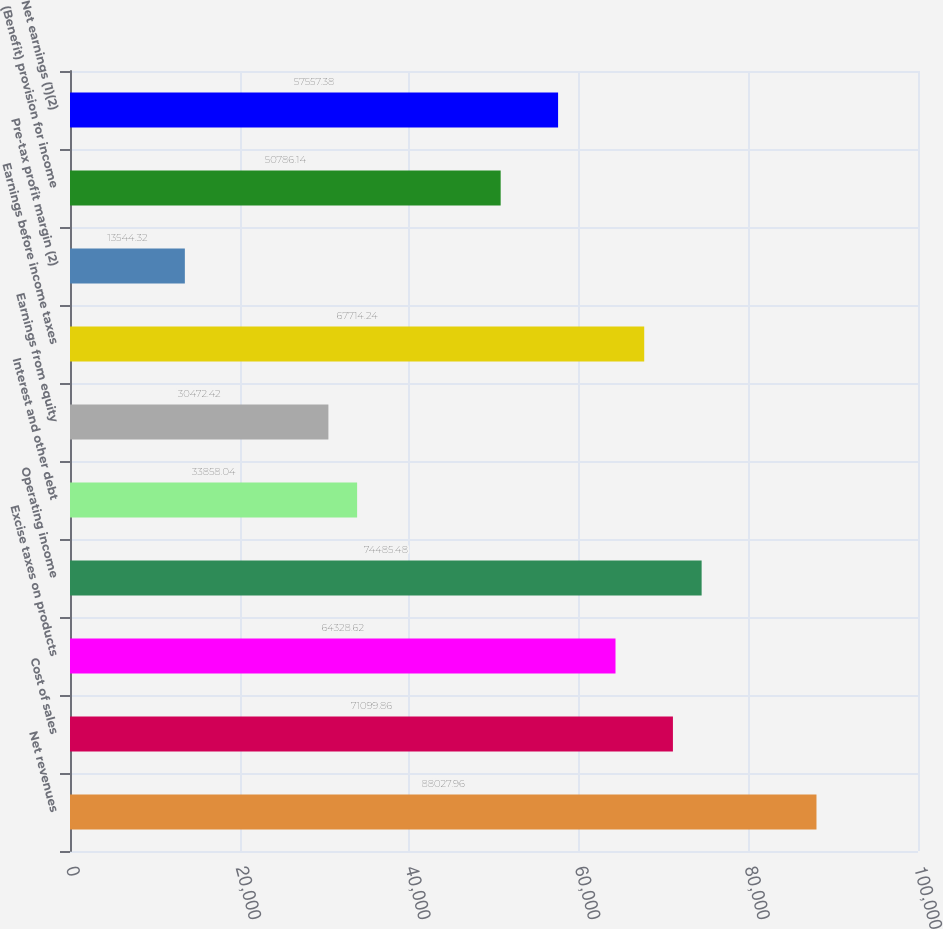<chart> <loc_0><loc_0><loc_500><loc_500><bar_chart><fcel>Net revenues<fcel>Cost of sales<fcel>Excise taxes on products<fcel>Operating income<fcel>Interest and other debt<fcel>Earnings from equity<fcel>Earnings before income taxes<fcel>Pre-tax profit margin (2)<fcel>(Benefit) provision for income<fcel>Net earnings (1)(2)<nl><fcel>88028<fcel>71099.9<fcel>64328.6<fcel>74485.5<fcel>33858<fcel>30472.4<fcel>67714.2<fcel>13544.3<fcel>50786.1<fcel>57557.4<nl></chart> 